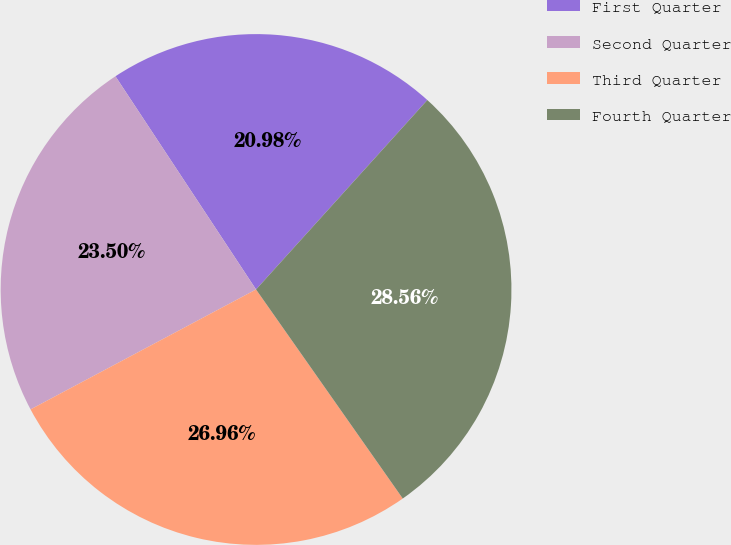Convert chart. <chart><loc_0><loc_0><loc_500><loc_500><pie_chart><fcel>First Quarter<fcel>Second Quarter<fcel>Third Quarter<fcel>Fourth Quarter<nl><fcel>20.98%<fcel>23.5%<fcel>26.96%<fcel>28.56%<nl></chart> 